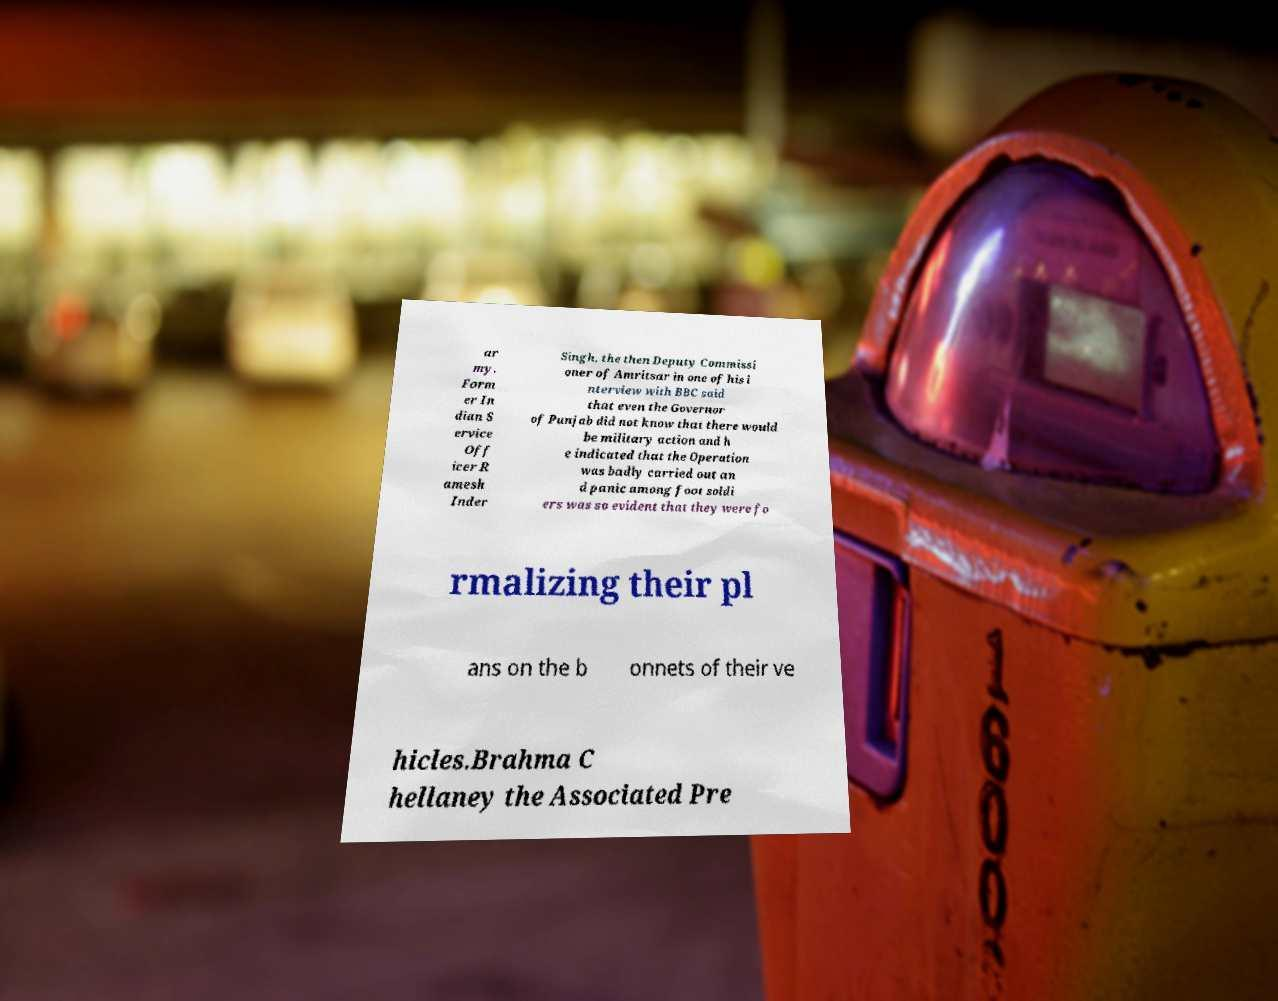Can you read and provide the text displayed in the image?This photo seems to have some interesting text. Can you extract and type it out for me? ar my. Form er In dian S ervice Off icer R amesh Inder Singh, the then Deputy Commissi oner of Amritsar in one of his i nterview with BBC said that even the Governor of Punjab did not know that there would be military action and h e indicated that the Operation was badly carried out an d panic among foot soldi ers was so evident that they were fo rmalizing their pl ans on the b onnets of their ve hicles.Brahma C hellaney the Associated Pre 